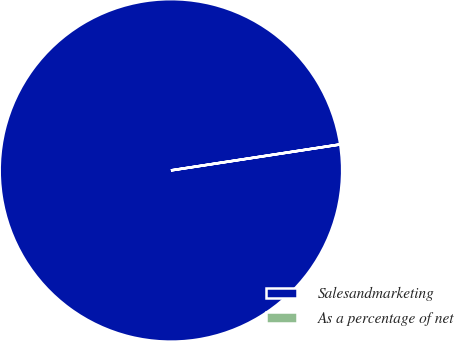Convert chart to OTSL. <chart><loc_0><loc_0><loc_500><loc_500><pie_chart><fcel>Salesandmarketing<fcel>As a percentage of net<nl><fcel>100.0%<fcel>0.0%<nl></chart> 